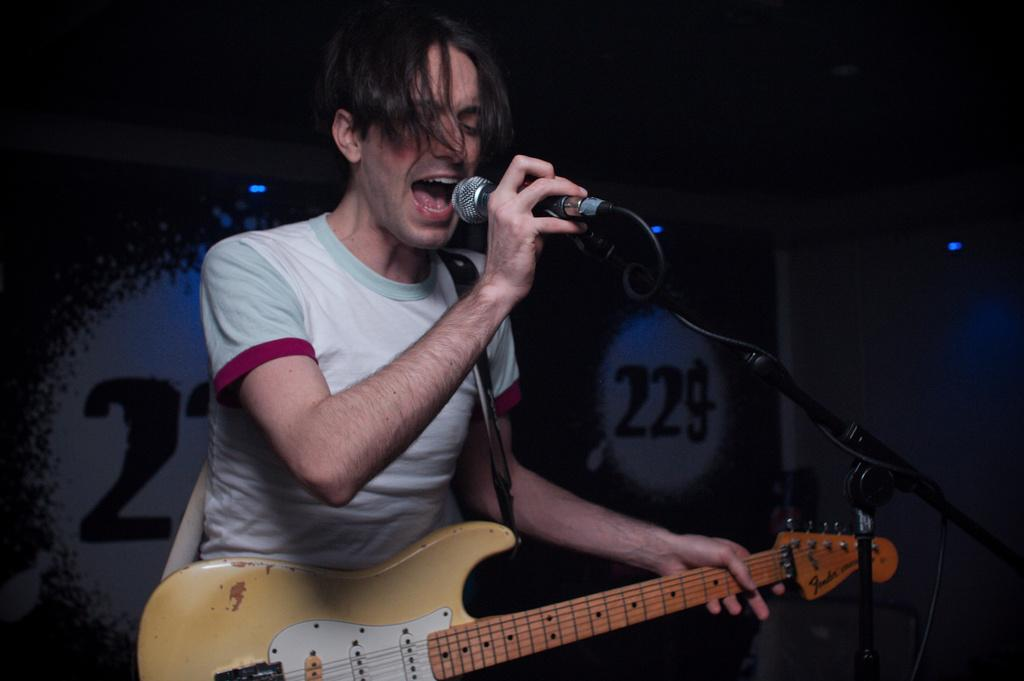What is the main subject of the image? There is a person in the image. What is the person doing in the image? The person is standing in the image. What objects is the person holding? The person is holding a guitar and a microphone (mic) in the image. What type of potato is the person smashing in the image? There is no potato present in the image, and the person is not smashing anything. 